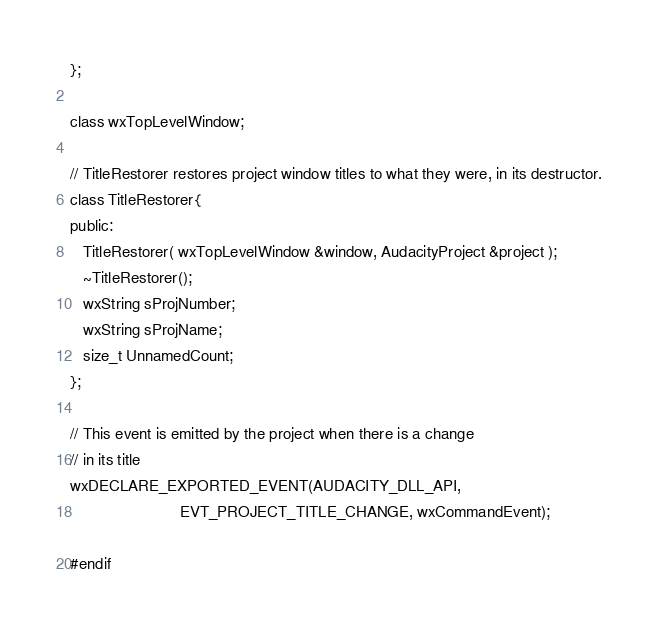<code> <loc_0><loc_0><loc_500><loc_500><_C_>};

class wxTopLevelWindow;

// TitleRestorer restores project window titles to what they were, in its destructor.
class TitleRestorer{
public:
   TitleRestorer( wxTopLevelWindow &window, AudacityProject &project );
   ~TitleRestorer();
   wxString sProjNumber;
   wxString sProjName;
   size_t UnnamedCount;
};

// This event is emitted by the project when there is a change
// in its title
wxDECLARE_EXPORTED_EVENT(AUDACITY_DLL_API,
                         EVT_PROJECT_TITLE_CHANGE, wxCommandEvent);

#endif
</code> 